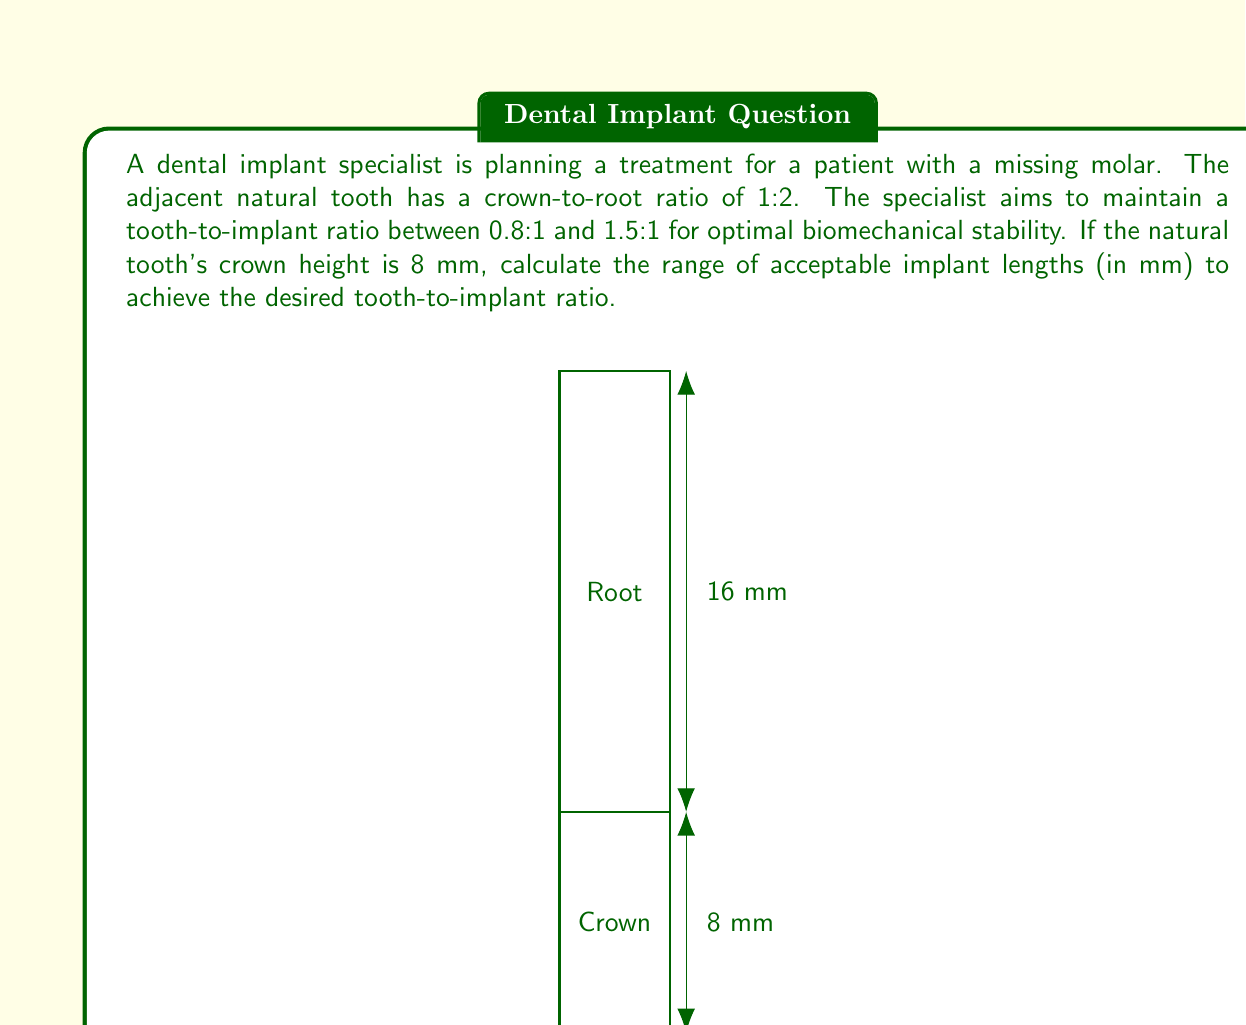Give your solution to this math problem. Let's approach this step-by-step:

1) First, we need to calculate the total height of the natural tooth:
   Crown height = 8 mm
   Crown-to-root ratio = 1:2
   Root height = 2 * 8 = 16 mm
   Total tooth height = 8 + 16 = 24 mm

2) Now, we need to find the range of implant lengths that will satisfy the desired tooth-to-implant ratio:

   Lower limit: 0.8:1
   Upper limit: 1.5:1

3) For the lower limit (0.8:1):
   $\frac{\text{Tooth height}}{\text{Implant length}} = 0.8$
   $\frac{24}{\text{Implant length}} = 0.8$
   Implant length = $\frac{24}{0.8} = 30$ mm

4) For the upper limit (1.5:1):
   $\frac{\text{Tooth height}}{\text{Implant length}} = 1.5$
   $\frac{24}{\text{Implant length}} = 1.5$
   Implant length = $\frac{24}{1.5} = 16$ mm

5) Therefore, the range of acceptable implant lengths is from 16 mm to 30 mm.
Answer: 16 mm to 30 mm 